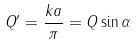Convert formula to latex. <formula><loc_0><loc_0><loc_500><loc_500>Q ^ { \prime } = \frac { k a } { \pi } = Q \sin \alpha</formula> 